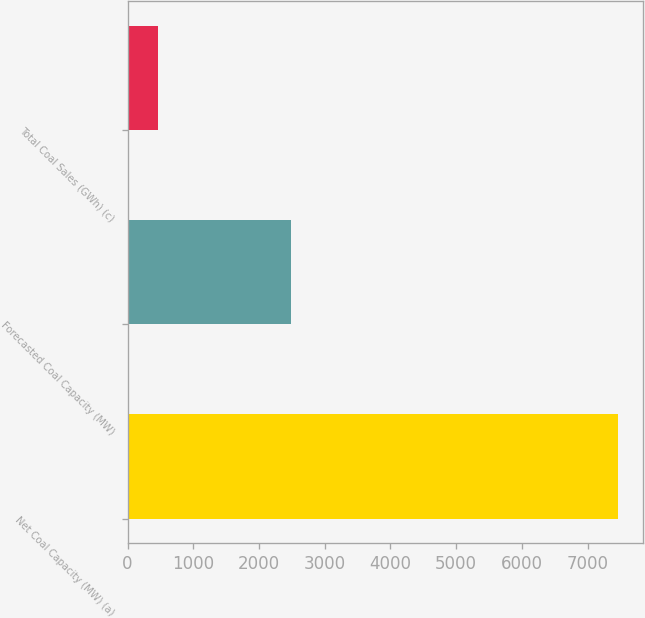Convert chart. <chart><loc_0><loc_0><loc_500><loc_500><bar_chart><fcel>Net Coal Capacity (MW) (a)<fcel>Forecasted Coal Capacity (MW)<fcel>Total Coal Sales (GWh) (c)<nl><fcel>7465<fcel>2483<fcel>455<nl></chart> 